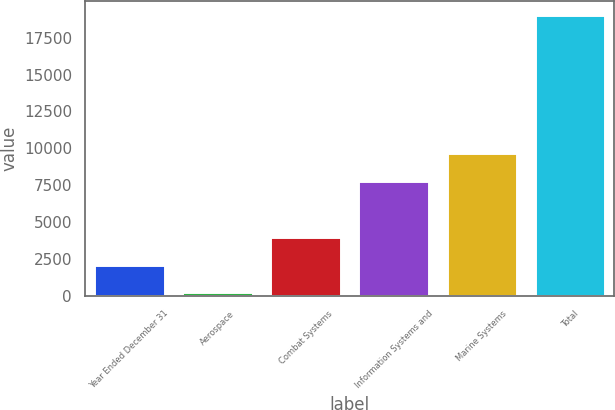Convert chart to OTSL. <chart><loc_0><loc_0><loc_500><loc_500><bar_chart><fcel>Year Ended December 31<fcel>Aerospace<fcel>Combat Systems<fcel>Information Systems and<fcel>Marine Systems<fcel>Total<nl><fcel>2110<fcel>231<fcel>3989<fcel>7793<fcel>9672<fcel>19021<nl></chart> 